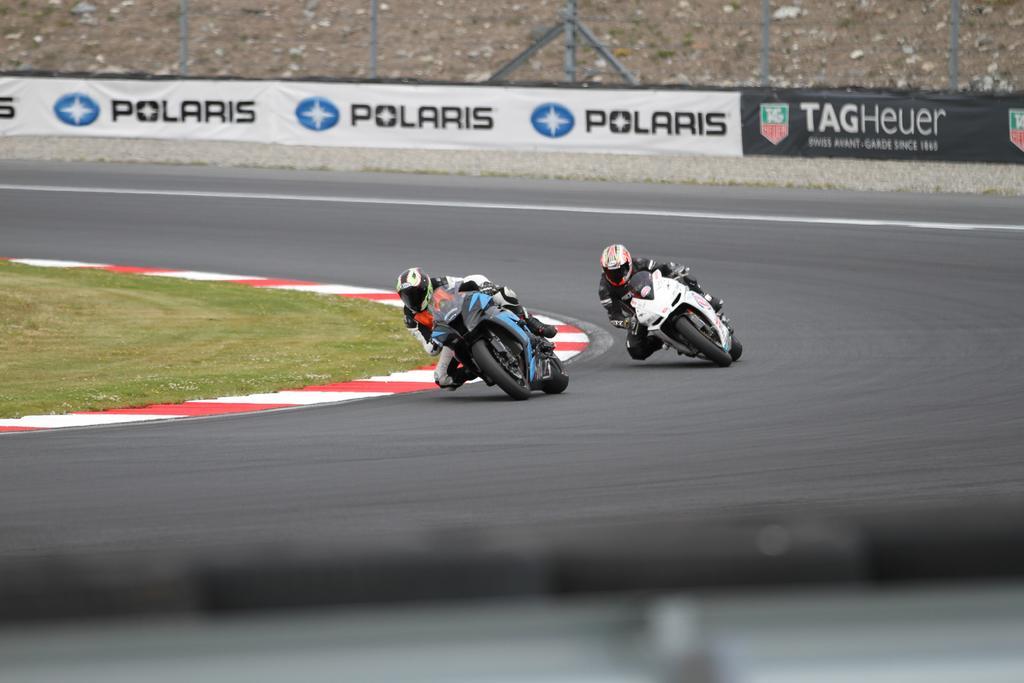Please provide a concise description of this image. this is completely an outdoor picture and on the background we can see a mesh and this is a hoarding. Two persons are participating in bike racing. In the middle we can see a green grass with a red and white paint around it. This is a road. 